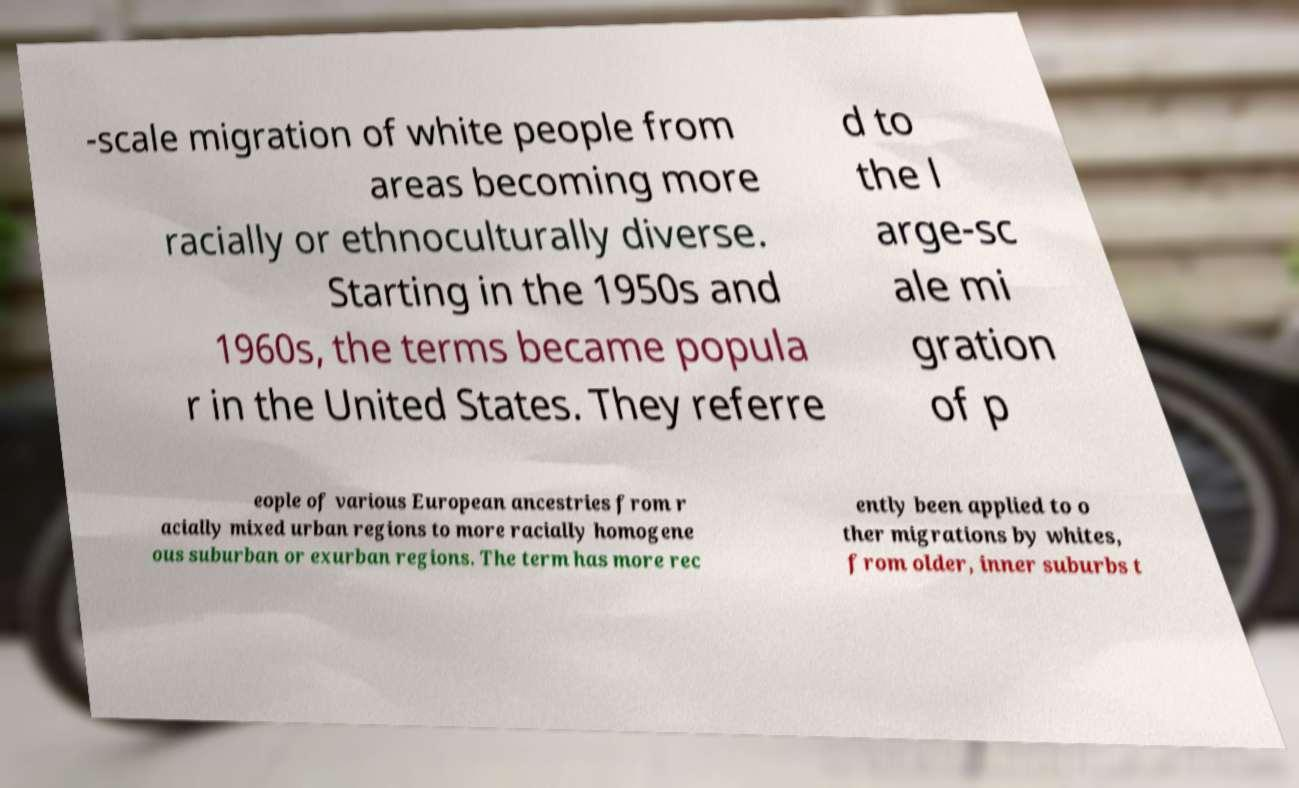Can you accurately transcribe the text from the provided image for me? -scale migration of white people from areas becoming more racially or ethnoculturally diverse. Starting in the 1950s and 1960s, the terms became popula r in the United States. They referre d to the l arge-sc ale mi gration of p eople of various European ancestries from r acially mixed urban regions to more racially homogene ous suburban or exurban regions. The term has more rec ently been applied to o ther migrations by whites, from older, inner suburbs t 